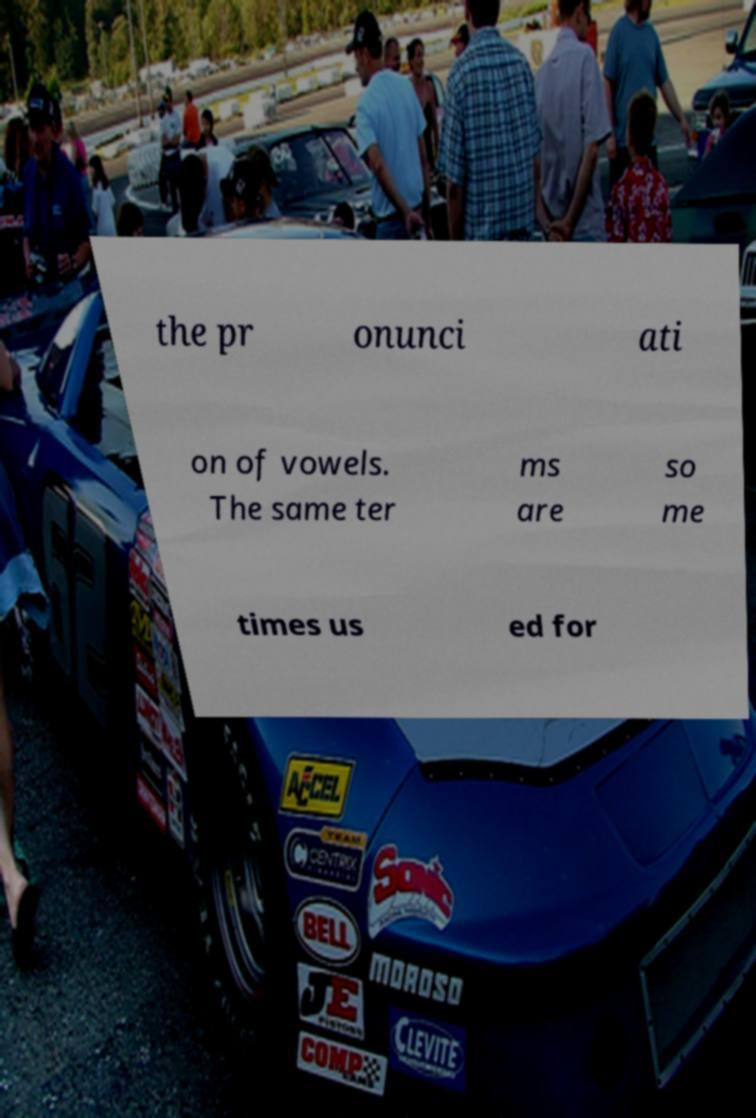Could you extract and type out the text from this image? the pr onunci ati on of vowels. The same ter ms are so me times us ed for 